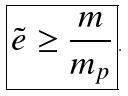Convert formula to latex. <formula><loc_0><loc_0><loc_500><loc_500>\boxed { \tilde { e } \geq \frac { m } { m _ { p } } } .</formula> 